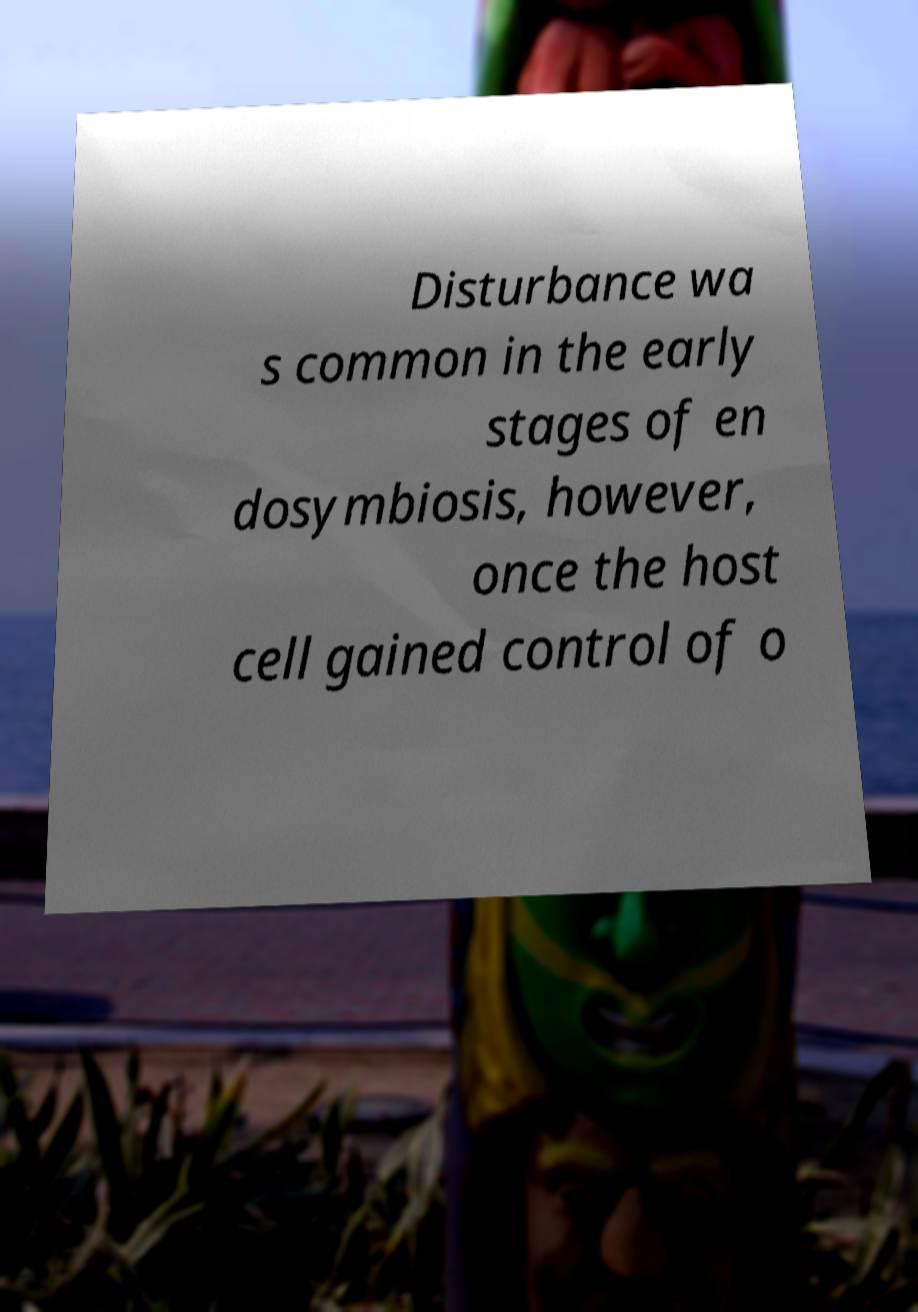Please identify and transcribe the text found in this image. Disturbance wa s common in the early stages of en dosymbiosis, however, once the host cell gained control of o 